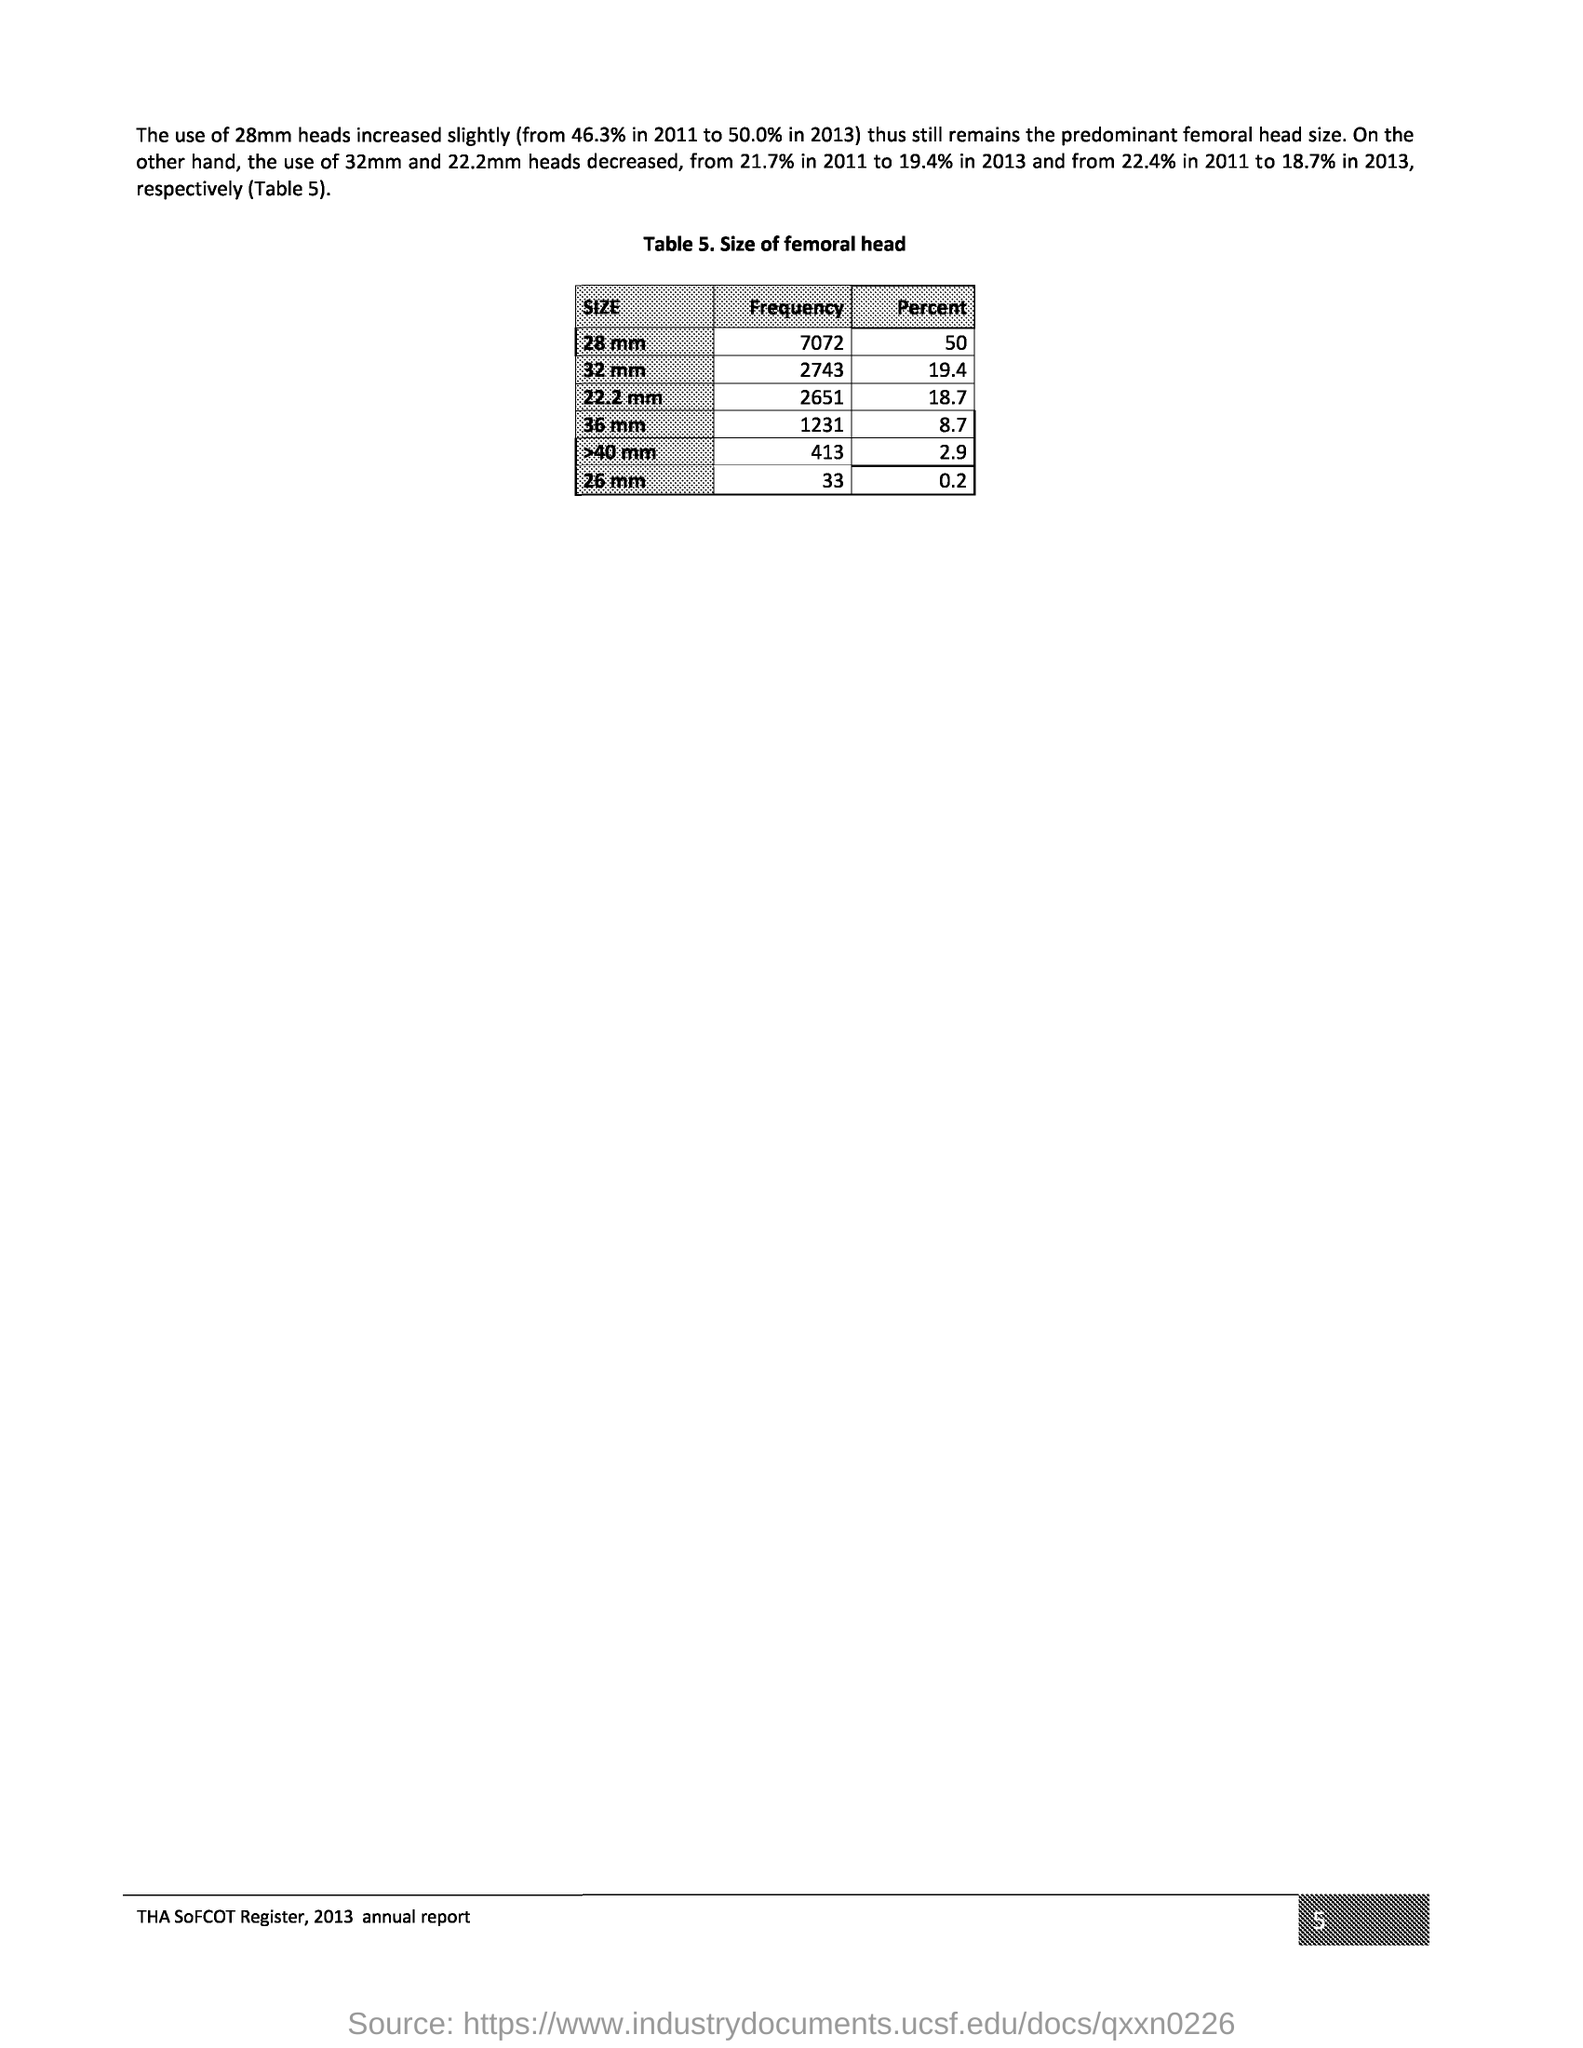What does Table 5. represent?
Offer a terse response. Size of femoral head. What is the page no mentioned in this document?
Your response must be concise. 5. 